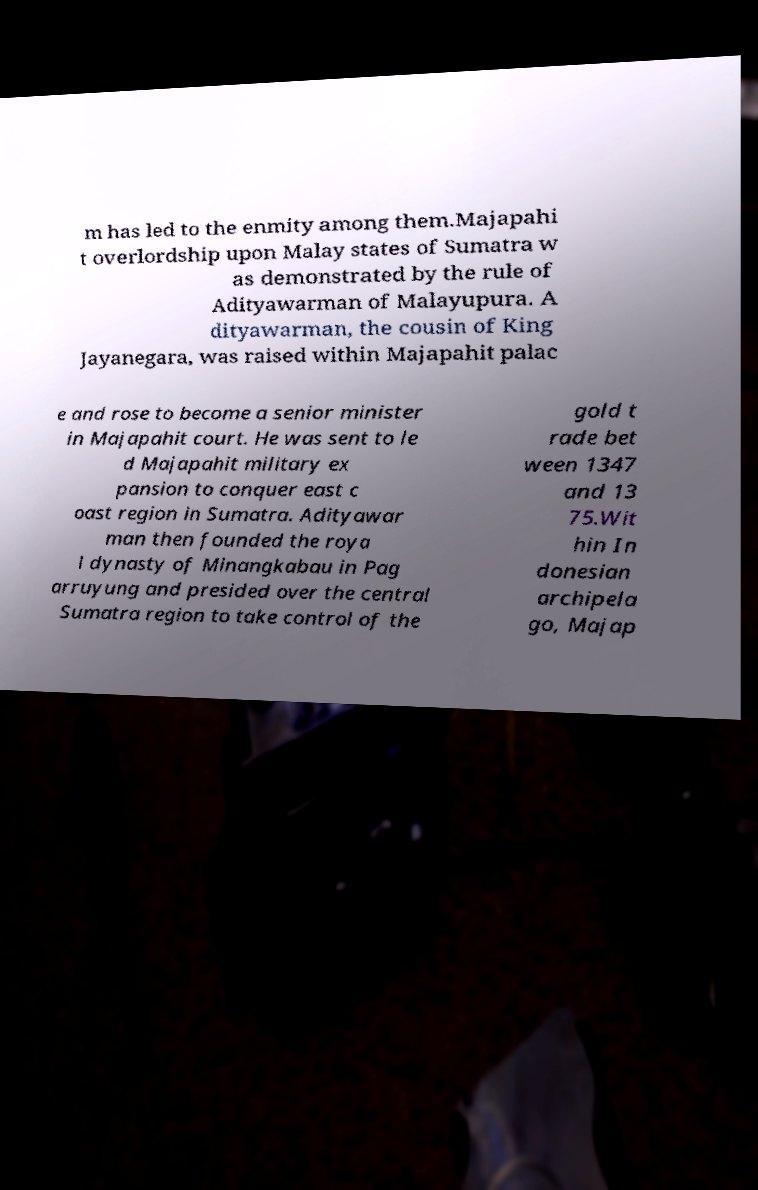There's text embedded in this image that I need extracted. Can you transcribe it verbatim? m has led to the enmity among them.Majapahi t overlordship upon Malay states of Sumatra w as demonstrated by the rule of Adityawarman of Malayupura. A dityawarman, the cousin of King Jayanegara, was raised within Majapahit palac e and rose to become a senior minister in Majapahit court. He was sent to le d Majapahit military ex pansion to conquer east c oast region in Sumatra. Adityawar man then founded the roya l dynasty of Minangkabau in Pag arruyung and presided over the central Sumatra region to take control of the gold t rade bet ween 1347 and 13 75.Wit hin In donesian archipela go, Majap 